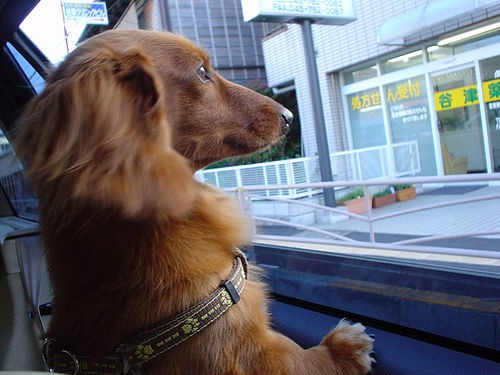Describe the objects in this image and their specific colors. I can see dog in black, maroon, and gray tones, potted plant in black, lightpink, darkgray, and teal tones, potted plant in black, gray, and teal tones, and potted plant in black, gray, tan, and teal tones in this image. 